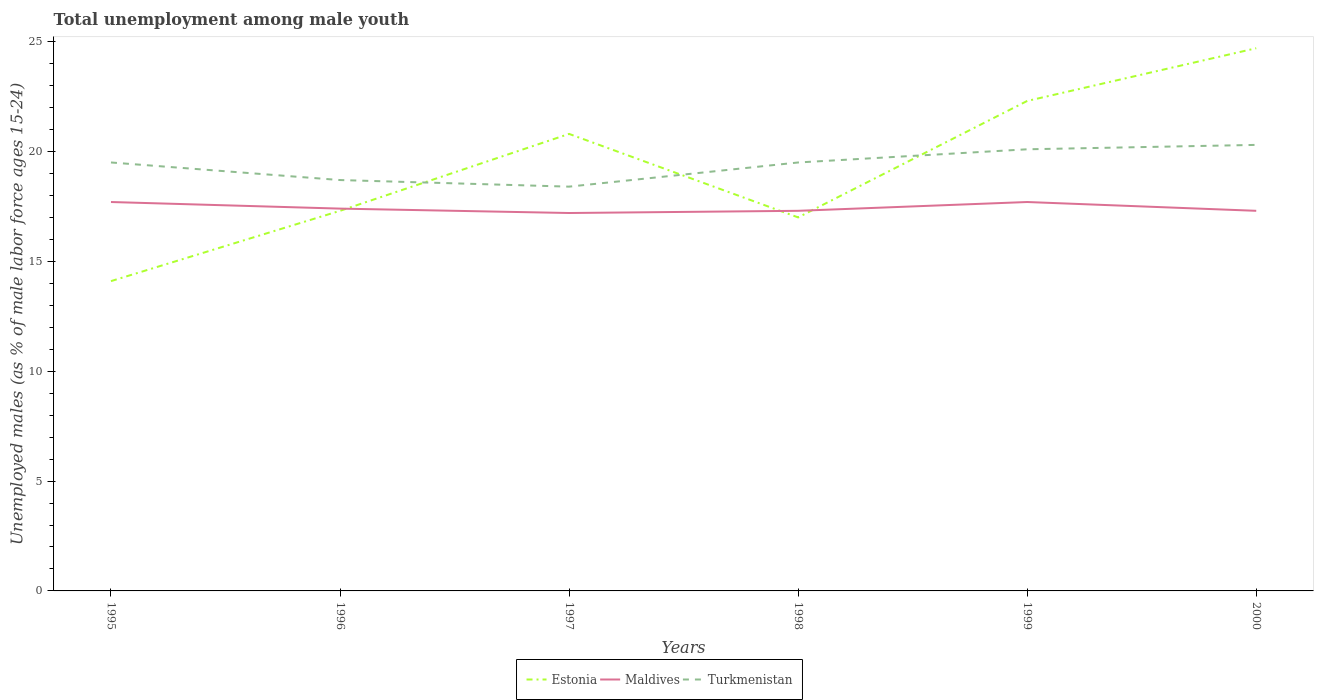How many different coloured lines are there?
Your response must be concise. 3. Does the line corresponding to Maldives intersect with the line corresponding to Turkmenistan?
Ensure brevity in your answer.  No. Across all years, what is the maximum percentage of unemployed males in in Estonia?
Your answer should be compact. 14.1. In which year was the percentage of unemployed males in in Turkmenistan maximum?
Offer a terse response. 1997. What is the total percentage of unemployed males in in Estonia in the graph?
Your answer should be very brief. -3.9. What is the difference between the highest and the second highest percentage of unemployed males in in Estonia?
Your response must be concise. 10.6. What is the difference between the highest and the lowest percentage of unemployed males in in Estonia?
Provide a succinct answer. 3. Is the percentage of unemployed males in in Maldives strictly greater than the percentage of unemployed males in in Estonia over the years?
Make the answer very short. No. How many lines are there?
Offer a terse response. 3. What is the difference between two consecutive major ticks on the Y-axis?
Your response must be concise. 5. Are the values on the major ticks of Y-axis written in scientific E-notation?
Provide a short and direct response. No. Does the graph contain any zero values?
Provide a succinct answer. No. Does the graph contain grids?
Provide a short and direct response. No. Where does the legend appear in the graph?
Ensure brevity in your answer.  Bottom center. How many legend labels are there?
Provide a short and direct response. 3. What is the title of the graph?
Give a very brief answer. Total unemployment among male youth. Does "New Zealand" appear as one of the legend labels in the graph?
Your answer should be compact. No. What is the label or title of the Y-axis?
Ensure brevity in your answer.  Unemployed males (as % of male labor force ages 15-24). What is the Unemployed males (as % of male labor force ages 15-24) in Estonia in 1995?
Your response must be concise. 14.1. What is the Unemployed males (as % of male labor force ages 15-24) in Maldives in 1995?
Your answer should be very brief. 17.7. What is the Unemployed males (as % of male labor force ages 15-24) of Estonia in 1996?
Keep it short and to the point. 17.3. What is the Unemployed males (as % of male labor force ages 15-24) in Maldives in 1996?
Ensure brevity in your answer.  17.4. What is the Unemployed males (as % of male labor force ages 15-24) of Turkmenistan in 1996?
Ensure brevity in your answer.  18.7. What is the Unemployed males (as % of male labor force ages 15-24) of Estonia in 1997?
Make the answer very short. 20.8. What is the Unemployed males (as % of male labor force ages 15-24) of Maldives in 1997?
Ensure brevity in your answer.  17.2. What is the Unemployed males (as % of male labor force ages 15-24) of Turkmenistan in 1997?
Your response must be concise. 18.4. What is the Unemployed males (as % of male labor force ages 15-24) in Maldives in 1998?
Your answer should be very brief. 17.3. What is the Unemployed males (as % of male labor force ages 15-24) of Turkmenistan in 1998?
Your answer should be very brief. 19.5. What is the Unemployed males (as % of male labor force ages 15-24) in Estonia in 1999?
Your response must be concise. 22.3. What is the Unemployed males (as % of male labor force ages 15-24) of Maldives in 1999?
Your response must be concise. 17.7. What is the Unemployed males (as % of male labor force ages 15-24) of Turkmenistan in 1999?
Your answer should be compact. 20.1. What is the Unemployed males (as % of male labor force ages 15-24) of Estonia in 2000?
Give a very brief answer. 24.7. What is the Unemployed males (as % of male labor force ages 15-24) in Maldives in 2000?
Provide a short and direct response. 17.3. What is the Unemployed males (as % of male labor force ages 15-24) in Turkmenistan in 2000?
Ensure brevity in your answer.  20.3. Across all years, what is the maximum Unemployed males (as % of male labor force ages 15-24) of Estonia?
Keep it short and to the point. 24.7. Across all years, what is the maximum Unemployed males (as % of male labor force ages 15-24) in Maldives?
Your answer should be very brief. 17.7. Across all years, what is the maximum Unemployed males (as % of male labor force ages 15-24) in Turkmenistan?
Give a very brief answer. 20.3. Across all years, what is the minimum Unemployed males (as % of male labor force ages 15-24) of Estonia?
Ensure brevity in your answer.  14.1. Across all years, what is the minimum Unemployed males (as % of male labor force ages 15-24) in Maldives?
Give a very brief answer. 17.2. Across all years, what is the minimum Unemployed males (as % of male labor force ages 15-24) of Turkmenistan?
Offer a terse response. 18.4. What is the total Unemployed males (as % of male labor force ages 15-24) in Estonia in the graph?
Your response must be concise. 116.2. What is the total Unemployed males (as % of male labor force ages 15-24) in Maldives in the graph?
Provide a succinct answer. 104.6. What is the total Unemployed males (as % of male labor force ages 15-24) of Turkmenistan in the graph?
Your response must be concise. 116.5. What is the difference between the Unemployed males (as % of male labor force ages 15-24) of Maldives in 1995 and that in 1996?
Make the answer very short. 0.3. What is the difference between the Unemployed males (as % of male labor force ages 15-24) of Estonia in 1995 and that in 1997?
Provide a succinct answer. -6.7. What is the difference between the Unemployed males (as % of male labor force ages 15-24) of Estonia in 1995 and that in 1998?
Offer a very short reply. -2.9. What is the difference between the Unemployed males (as % of male labor force ages 15-24) of Maldives in 1995 and that in 1998?
Your answer should be very brief. 0.4. What is the difference between the Unemployed males (as % of male labor force ages 15-24) of Estonia in 1995 and that in 1999?
Ensure brevity in your answer.  -8.2. What is the difference between the Unemployed males (as % of male labor force ages 15-24) in Maldives in 1995 and that in 1999?
Your answer should be compact. 0. What is the difference between the Unemployed males (as % of male labor force ages 15-24) in Turkmenistan in 1995 and that in 1999?
Provide a short and direct response. -0.6. What is the difference between the Unemployed males (as % of male labor force ages 15-24) of Estonia in 1995 and that in 2000?
Your answer should be very brief. -10.6. What is the difference between the Unemployed males (as % of male labor force ages 15-24) in Maldives in 1995 and that in 2000?
Offer a terse response. 0.4. What is the difference between the Unemployed males (as % of male labor force ages 15-24) of Turkmenistan in 1995 and that in 2000?
Make the answer very short. -0.8. What is the difference between the Unemployed males (as % of male labor force ages 15-24) of Maldives in 1996 and that in 1997?
Offer a very short reply. 0.2. What is the difference between the Unemployed males (as % of male labor force ages 15-24) of Estonia in 1996 and that in 1998?
Offer a terse response. 0.3. What is the difference between the Unemployed males (as % of male labor force ages 15-24) of Maldives in 1996 and that in 1998?
Give a very brief answer. 0.1. What is the difference between the Unemployed males (as % of male labor force ages 15-24) in Turkmenistan in 1996 and that in 1998?
Provide a succinct answer. -0.8. What is the difference between the Unemployed males (as % of male labor force ages 15-24) of Turkmenistan in 1996 and that in 1999?
Your answer should be very brief. -1.4. What is the difference between the Unemployed males (as % of male labor force ages 15-24) in Turkmenistan in 1996 and that in 2000?
Your answer should be compact. -1.6. What is the difference between the Unemployed males (as % of male labor force ages 15-24) in Maldives in 1997 and that in 1998?
Your answer should be compact. -0.1. What is the difference between the Unemployed males (as % of male labor force ages 15-24) in Turkmenistan in 1997 and that in 1998?
Your answer should be compact. -1.1. What is the difference between the Unemployed males (as % of male labor force ages 15-24) in Maldives in 1997 and that in 1999?
Ensure brevity in your answer.  -0.5. What is the difference between the Unemployed males (as % of male labor force ages 15-24) in Maldives in 1997 and that in 2000?
Your response must be concise. -0.1. What is the difference between the Unemployed males (as % of male labor force ages 15-24) of Estonia in 1998 and that in 1999?
Keep it short and to the point. -5.3. What is the difference between the Unemployed males (as % of male labor force ages 15-24) of Turkmenistan in 1998 and that in 1999?
Your answer should be very brief. -0.6. What is the difference between the Unemployed males (as % of male labor force ages 15-24) of Estonia in 1998 and that in 2000?
Make the answer very short. -7.7. What is the difference between the Unemployed males (as % of male labor force ages 15-24) in Maldives in 1999 and that in 2000?
Your response must be concise. 0.4. What is the difference between the Unemployed males (as % of male labor force ages 15-24) in Estonia in 1995 and the Unemployed males (as % of male labor force ages 15-24) in Turkmenistan in 1996?
Give a very brief answer. -4.6. What is the difference between the Unemployed males (as % of male labor force ages 15-24) of Estonia in 1995 and the Unemployed males (as % of male labor force ages 15-24) of Turkmenistan in 1997?
Your answer should be compact. -4.3. What is the difference between the Unemployed males (as % of male labor force ages 15-24) in Maldives in 1995 and the Unemployed males (as % of male labor force ages 15-24) in Turkmenistan in 1997?
Your response must be concise. -0.7. What is the difference between the Unemployed males (as % of male labor force ages 15-24) of Estonia in 1995 and the Unemployed males (as % of male labor force ages 15-24) of Maldives in 1998?
Offer a terse response. -3.2. What is the difference between the Unemployed males (as % of male labor force ages 15-24) in Estonia in 1995 and the Unemployed males (as % of male labor force ages 15-24) in Turkmenistan in 1998?
Keep it short and to the point. -5.4. What is the difference between the Unemployed males (as % of male labor force ages 15-24) of Maldives in 1995 and the Unemployed males (as % of male labor force ages 15-24) of Turkmenistan in 1998?
Give a very brief answer. -1.8. What is the difference between the Unemployed males (as % of male labor force ages 15-24) of Estonia in 1995 and the Unemployed males (as % of male labor force ages 15-24) of Maldives in 1999?
Your answer should be compact. -3.6. What is the difference between the Unemployed males (as % of male labor force ages 15-24) of Estonia in 1995 and the Unemployed males (as % of male labor force ages 15-24) of Turkmenistan in 1999?
Make the answer very short. -6. What is the difference between the Unemployed males (as % of male labor force ages 15-24) in Maldives in 1995 and the Unemployed males (as % of male labor force ages 15-24) in Turkmenistan in 1999?
Provide a short and direct response. -2.4. What is the difference between the Unemployed males (as % of male labor force ages 15-24) in Estonia in 1996 and the Unemployed males (as % of male labor force ages 15-24) in Turkmenistan in 1997?
Your response must be concise. -1.1. What is the difference between the Unemployed males (as % of male labor force ages 15-24) of Maldives in 1996 and the Unemployed males (as % of male labor force ages 15-24) of Turkmenistan in 1997?
Your response must be concise. -1. What is the difference between the Unemployed males (as % of male labor force ages 15-24) of Estonia in 1996 and the Unemployed males (as % of male labor force ages 15-24) of Maldives in 2000?
Provide a short and direct response. 0. What is the difference between the Unemployed males (as % of male labor force ages 15-24) in Maldives in 1997 and the Unemployed males (as % of male labor force ages 15-24) in Turkmenistan in 1998?
Your answer should be very brief. -2.3. What is the difference between the Unemployed males (as % of male labor force ages 15-24) in Estonia in 1997 and the Unemployed males (as % of male labor force ages 15-24) in Maldives in 1999?
Your answer should be compact. 3.1. What is the difference between the Unemployed males (as % of male labor force ages 15-24) in Estonia in 1997 and the Unemployed males (as % of male labor force ages 15-24) in Turkmenistan in 2000?
Offer a very short reply. 0.5. What is the difference between the Unemployed males (as % of male labor force ages 15-24) in Maldives in 1997 and the Unemployed males (as % of male labor force ages 15-24) in Turkmenistan in 2000?
Your answer should be very brief. -3.1. What is the difference between the Unemployed males (as % of male labor force ages 15-24) in Maldives in 1998 and the Unemployed males (as % of male labor force ages 15-24) in Turkmenistan in 1999?
Keep it short and to the point. -2.8. What is the difference between the Unemployed males (as % of male labor force ages 15-24) of Maldives in 1998 and the Unemployed males (as % of male labor force ages 15-24) of Turkmenistan in 2000?
Your response must be concise. -3. What is the average Unemployed males (as % of male labor force ages 15-24) in Estonia per year?
Your answer should be compact. 19.37. What is the average Unemployed males (as % of male labor force ages 15-24) of Maldives per year?
Ensure brevity in your answer.  17.43. What is the average Unemployed males (as % of male labor force ages 15-24) in Turkmenistan per year?
Give a very brief answer. 19.42. In the year 1995, what is the difference between the Unemployed males (as % of male labor force ages 15-24) of Estonia and Unemployed males (as % of male labor force ages 15-24) of Turkmenistan?
Give a very brief answer. -5.4. In the year 1995, what is the difference between the Unemployed males (as % of male labor force ages 15-24) of Maldives and Unemployed males (as % of male labor force ages 15-24) of Turkmenistan?
Provide a short and direct response. -1.8. In the year 1996, what is the difference between the Unemployed males (as % of male labor force ages 15-24) of Estonia and Unemployed males (as % of male labor force ages 15-24) of Turkmenistan?
Your response must be concise. -1.4. In the year 1997, what is the difference between the Unemployed males (as % of male labor force ages 15-24) in Estonia and Unemployed males (as % of male labor force ages 15-24) in Maldives?
Your answer should be very brief. 3.6. In the year 1999, what is the difference between the Unemployed males (as % of male labor force ages 15-24) of Maldives and Unemployed males (as % of male labor force ages 15-24) of Turkmenistan?
Make the answer very short. -2.4. What is the ratio of the Unemployed males (as % of male labor force ages 15-24) of Estonia in 1995 to that in 1996?
Ensure brevity in your answer.  0.81. What is the ratio of the Unemployed males (as % of male labor force ages 15-24) of Maldives in 1995 to that in 1996?
Ensure brevity in your answer.  1.02. What is the ratio of the Unemployed males (as % of male labor force ages 15-24) of Turkmenistan in 1995 to that in 1996?
Your answer should be compact. 1.04. What is the ratio of the Unemployed males (as % of male labor force ages 15-24) in Estonia in 1995 to that in 1997?
Give a very brief answer. 0.68. What is the ratio of the Unemployed males (as % of male labor force ages 15-24) of Maldives in 1995 to that in 1997?
Offer a terse response. 1.03. What is the ratio of the Unemployed males (as % of male labor force ages 15-24) of Turkmenistan in 1995 to that in 1997?
Your response must be concise. 1.06. What is the ratio of the Unemployed males (as % of male labor force ages 15-24) of Estonia in 1995 to that in 1998?
Provide a succinct answer. 0.83. What is the ratio of the Unemployed males (as % of male labor force ages 15-24) in Maldives in 1995 to that in 1998?
Offer a very short reply. 1.02. What is the ratio of the Unemployed males (as % of male labor force ages 15-24) in Turkmenistan in 1995 to that in 1998?
Your answer should be very brief. 1. What is the ratio of the Unemployed males (as % of male labor force ages 15-24) in Estonia in 1995 to that in 1999?
Provide a succinct answer. 0.63. What is the ratio of the Unemployed males (as % of male labor force ages 15-24) of Turkmenistan in 1995 to that in 1999?
Offer a terse response. 0.97. What is the ratio of the Unemployed males (as % of male labor force ages 15-24) of Estonia in 1995 to that in 2000?
Your response must be concise. 0.57. What is the ratio of the Unemployed males (as % of male labor force ages 15-24) of Maldives in 1995 to that in 2000?
Provide a short and direct response. 1.02. What is the ratio of the Unemployed males (as % of male labor force ages 15-24) of Turkmenistan in 1995 to that in 2000?
Make the answer very short. 0.96. What is the ratio of the Unemployed males (as % of male labor force ages 15-24) of Estonia in 1996 to that in 1997?
Your response must be concise. 0.83. What is the ratio of the Unemployed males (as % of male labor force ages 15-24) of Maldives in 1996 to that in 1997?
Give a very brief answer. 1.01. What is the ratio of the Unemployed males (as % of male labor force ages 15-24) of Turkmenistan in 1996 to that in 1997?
Ensure brevity in your answer.  1.02. What is the ratio of the Unemployed males (as % of male labor force ages 15-24) of Estonia in 1996 to that in 1998?
Offer a very short reply. 1.02. What is the ratio of the Unemployed males (as % of male labor force ages 15-24) in Maldives in 1996 to that in 1998?
Your answer should be compact. 1.01. What is the ratio of the Unemployed males (as % of male labor force ages 15-24) of Turkmenistan in 1996 to that in 1998?
Provide a short and direct response. 0.96. What is the ratio of the Unemployed males (as % of male labor force ages 15-24) of Estonia in 1996 to that in 1999?
Give a very brief answer. 0.78. What is the ratio of the Unemployed males (as % of male labor force ages 15-24) in Maldives in 1996 to that in 1999?
Keep it short and to the point. 0.98. What is the ratio of the Unemployed males (as % of male labor force ages 15-24) in Turkmenistan in 1996 to that in 1999?
Offer a terse response. 0.93. What is the ratio of the Unemployed males (as % of male labor force ages 15-24) in Estonia in 1996 to that in 2000?
Make the answer very short. 0.7. What is the ratio of the Unemployed males (as % of male labor force ages 15-24) of Maldives in 1996 to that in 2000?
Ensure brevity in your answer.  1.01. What is the ratio of the Unemployed males (as % of male labor force ages 15-24) in Turkmenistan in 1996 to that in 2000?
Your answer should be very brief. 0.92. What is the ratio of the Unemployed males (as % of male labor force ages 15-24) of Estonia in 1997 to that in 1998?
Give a very brief answer. 1.22. What is the ratio of the Unemployed males (as % of male labor force ages 15-24) in Turkmenistan in 1997 to that in 1998?
Offer a terse response. 0.94. What is the ratio of the Unemployed males (as % of male labor force ages 15-24) in Estonia in 1997 to that in 1999?
Give a very brief answer. 0.93. What is the ratio of the Unemployed males (as % of male labor force ages 15-24) in Maldives in 1997 to that in 1999?
Offer a terse response. 0.97. What is the ratio of the Unemployed males (as % of male labor force ages 15-24) of Turkmenistan in 1997 to that in 1999?
Offer a terse response. 0.92. What is the ratio of the Unemployed males (as % of male labor force ages 15-24) in Estonia in 1997 to that in 2000?
Provide a short and direct response. 0.84. What is the ratio of the Unemployed males (as % of male labor force ages 15-24) in Turkmenistan in 1997 to that in 2000?
Offer a very short reply. 0.91. What is the ratio of the Unemployed males (as % of male labor force ages 15-24) of Estonia in 1998 to that in 1999?
Your response must be concise. 0.76. What is the ratio of the Unemployed males (as % of male labor force ages 15-24) of Maldives in 1998 to that in 1999?
Offer a very short reply. 0.98. What is the ratio of the Unemployed males (as % of male labor force ages 15-24) of Turkmenistan in 1998 to that in 1999?
Ensure brevity in your answer.  0.97. What is the ratio of the Unemployed males (as % of male labor force ages 15-24) of Estonia in 1998 to that in 2000?
Ensure brevity in your answer.  0.69. What is the ratio of the Unemployed males (as % of male labor force ages 15-24) in Maldives in 1998 to that in 2000?
Offer a very short reply. 1. What is the ratio of the Unemployed males (as % of male labor force ages 15-24) in Turkmenistan in 1998 to that in 2000?
Your response must be concise. 0.96. What is the ratio of the Unemployed males (as % of male labor force ages 15-24) of Estonia in 1999 to that in 2000?
Your answer should be very brief. 0.9. What is the ratio of the Unemployed males (as % of male labor force ages 15-24) in Maldives in 1999 to that in 2000?
Provide a short and direct response. 1.02. What is the difference between the highest and the second highest Unemployed males (as % of male labor force ages 15-24) of Estonia?
Provide a short and direct response. 2.4. What is the difference between the highest and the lowest Unemployed males (as % of male labor force ages 15-24) of Estonia?
Provide a short and direct response. 10.6. What is the difference between the highest and the lowest Unemployed males (as % of male labor force ages 15-24) in Maldives?
Your response must be concise. 0.5. 